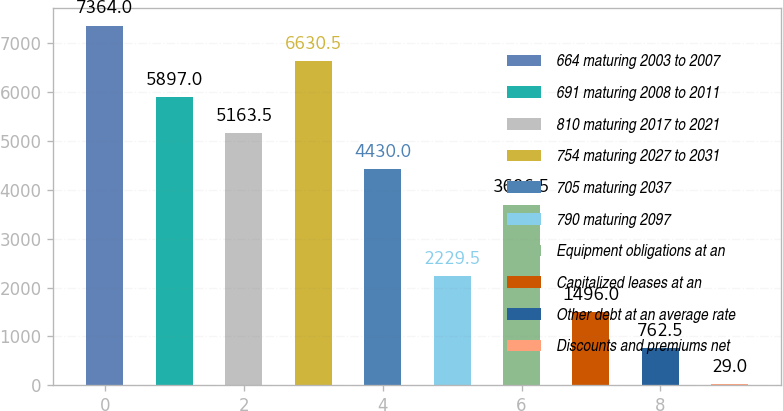Convert chart. <chart><loc_0><loc_0><loc_500><loc_500><bar_chart><fcel>664 maturing 2003 to 2007<fcel>691 maturing 2008 to 2011<fcel>810 maturing 2017 to 2021<fcel>754 maturing 2027 to 2031<fcel>705 maturing 2037<fcel>790 maturing 2097<fcel>Equipment obligations at an<fcel>Capitalized leases at an<fcel>Other debt at an average rate<fcel>Discounts and premiums net<nl><fcel>7364<fcel>5897<fcel>5163.5<fcel>6630.5<fcel>4430<fcel>2229.5<fcel>3696.5<fcel>1496<fcel>762.5<fcel>29<nl></chart> 